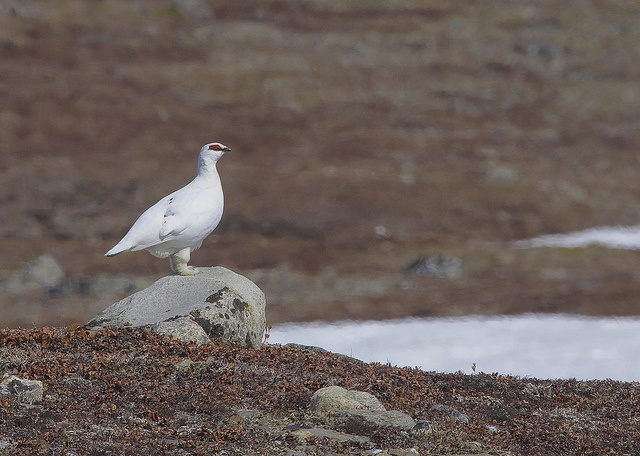Describe the objects in this image and their specific colors. I can see a bird in gray, lightgray, and darkgray tones in this image. 